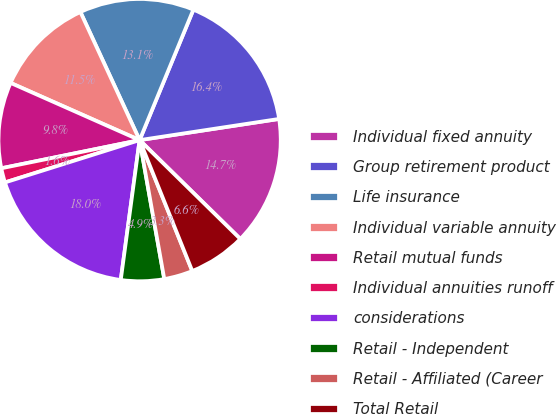Convert chart. <chart><loc_0><loc_0><loc_500><loc_500><pie_chart><fcel>Individual fixed annuity<fcel>Group retirement product<fcel>Life insurance<fcel>Individual variable annuity<fcel>Retail mutual funds<fcel>Individual annuities runoff<fcel>considerations<fcel>Retail - Independent<fcel>Retail - Affiliated (Career<fcel>Total Retail<nl><fcel>14.75%<fcel>16.38%<fcel>13.11%<fcel>11.47%<fcel>9.84%<fcel>1.65%<fcel>18.02%<fcel>4.93%<fcel>3.29%<fcel>6.56%<nl></chart> 